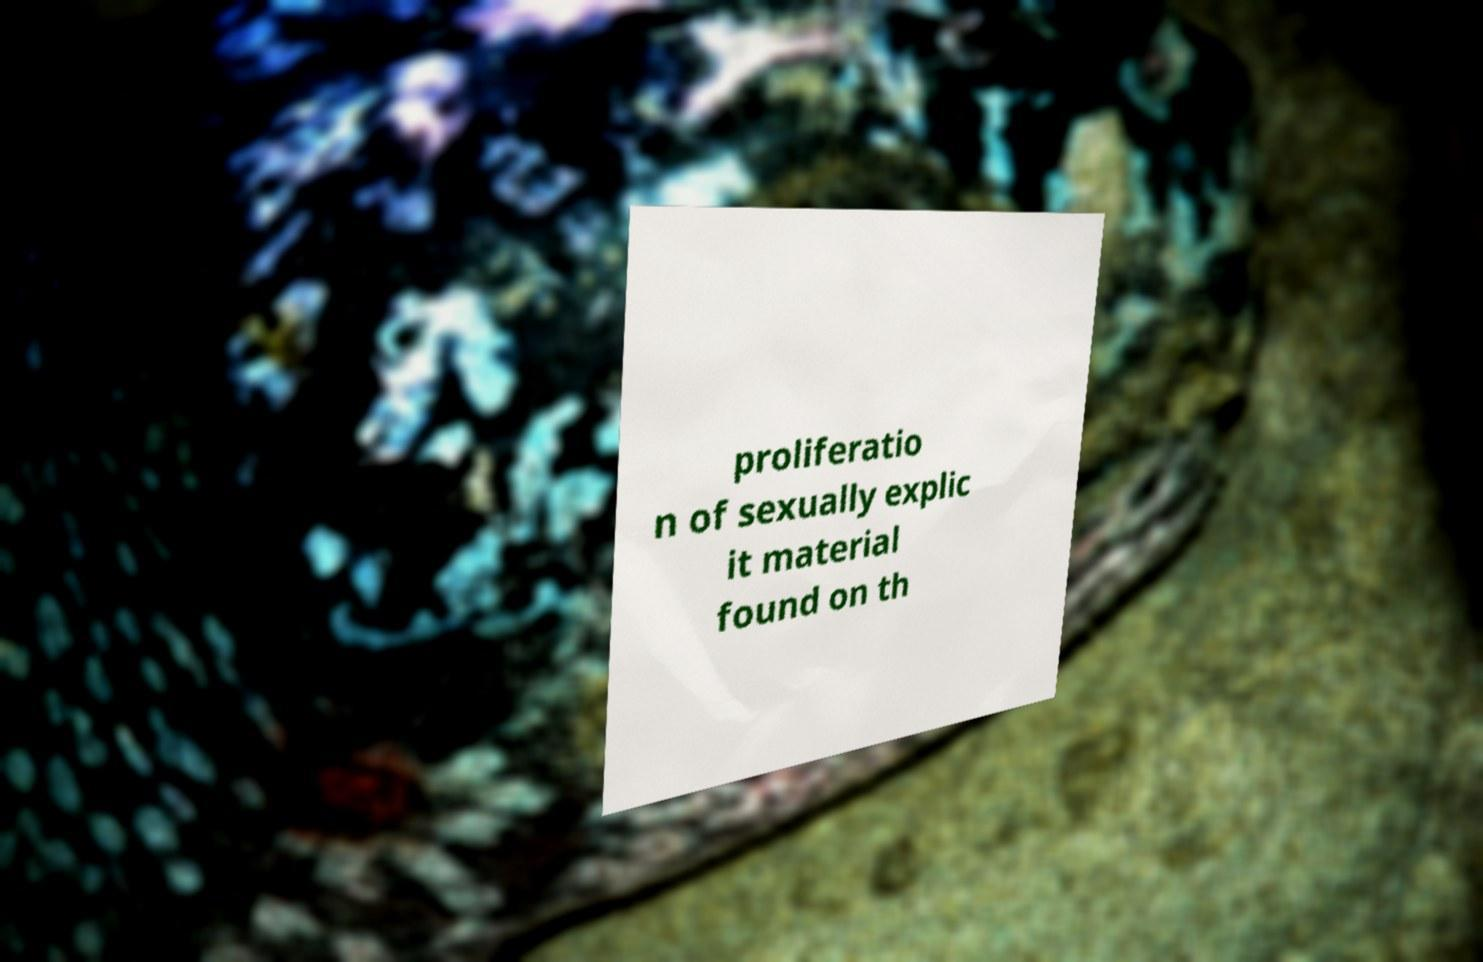For documentation purposes, I need the text within this image transcribed. Could you provide that? proliferatio n of sexually explic it material found on th 